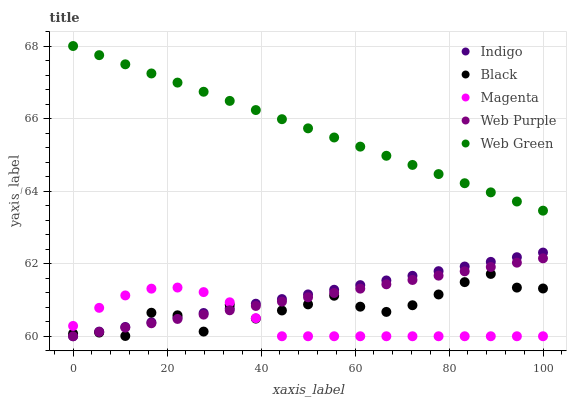Does Magenta have the minimum area under the curve?
Answer yes or no. Yes. Does Web Green have the maximum area under the curve?
Answer yes or no. Yes. Does Indigo have the minimum area under the curve?
Answer yes or no. No. Does Indigo have the maximum area under the curve?
Answer yes or no. No. Is Web Purple the smoothest?
Answer yes or no. Yes. Is Black the roughest?
Answer yes or no. Yes. Is Magenta the smoothest?
Answer yes or no. No. Is Magenta the roughest?
Answer yes or no. No. Does Magenta have the lowest value?
Answer yes or no. Yes. Does Web Green have the lowest value?
Answer yes or no. No. Does Web Green have the highest value?
Answer yes or no. Yes. Does Indigo have the highest value?
Answer yes or no. No. Is Black less than Web Green?
Answer yes or no. Yes. Is Web Green greater than Indigo?
Answer yes or no. Yes. Does Magenta intersect Web Purple?
Answer yes or no. Yes. Is Magenta less than Web Purple?
Answer yes or no. No. Is Magenta greater than Web Purple?
Answer yes or no. No. Does Black intersect Web Green?
Answer yes or no. No. 